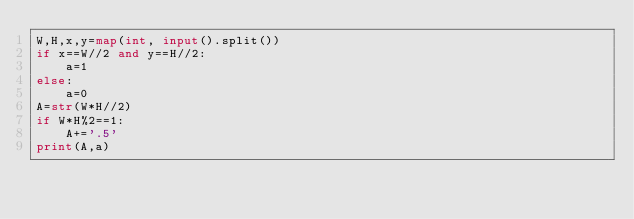<code> <loc_0><loc_0><loc_500><loc_500><_Python_>W,H,x,y=map(int, input().split())
if x==W//2 and y==H//2:
    a=1
else:
    a=0
A=str(W*H//2)
if W*H%2==1:
    A+='.5'
print(A,a)</code> 